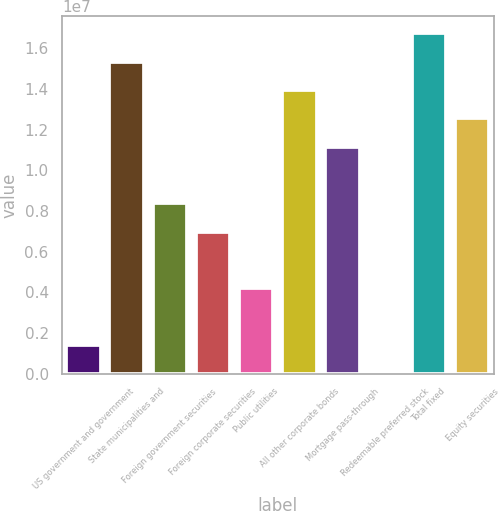Convert chart to OTSL. <chart><loc_0><loc_0><loc_500><loc_500><bar_chart><fcel>US government and government<fcel>State municipalities and<fcel>Foreign government securities<fcel>Foreign corporate securities<fcel>Public utilities<fcel>All other corporate bonds<fcel>Mortgage pass-through<fcel>Redeemable preferred stock<fcel>Total fixed<fcel>Equity securities<nl><fcel>1.40515e+06<fcel>1.53517e+07<fcel>8.37845e+06<fcel>6.98379e+06<fcel>4.19447e+06<fcel>1.39571e+07<fcel>1.11678e+07<fcel>10488<fcel>1.67464e+07<fcel>1.25624e+07<nl></chart> 